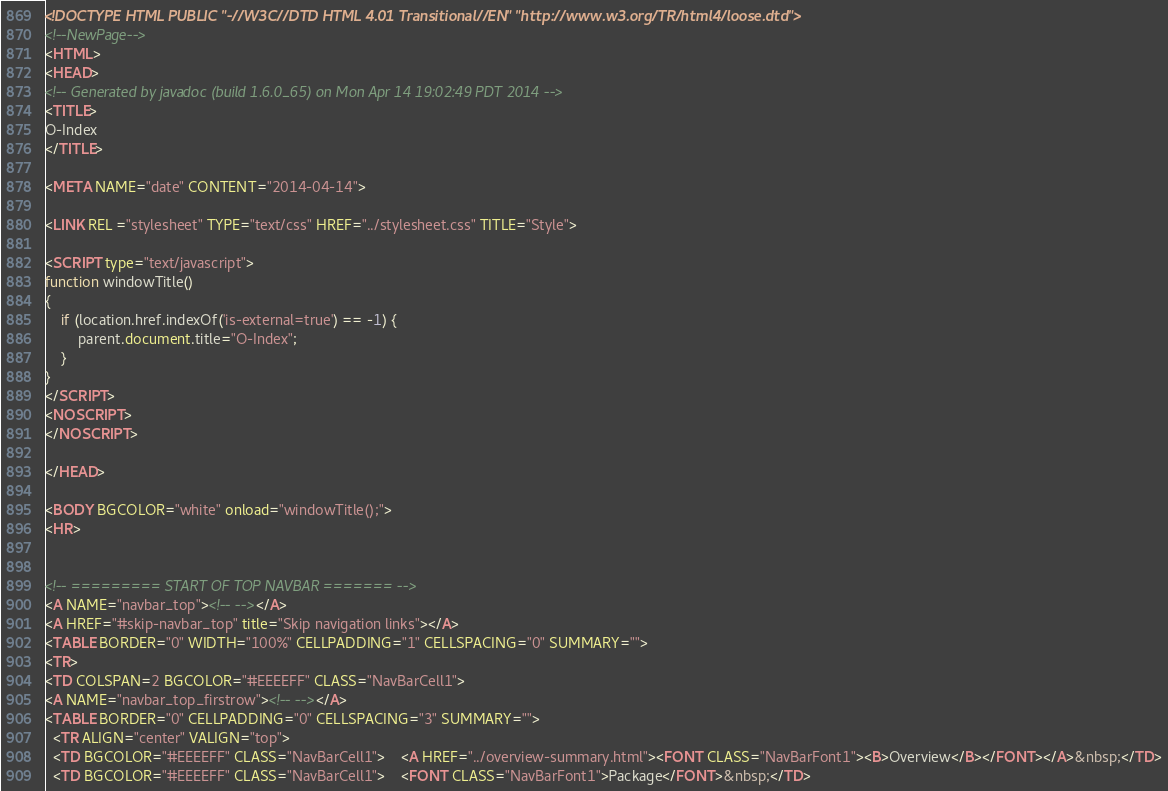<code> <loc_0><loc_0><loc_500><loc_500><_HTML_><!DOCTYPE HTML PUBLIC "-//W3C//DTD HTML 4.01 Transitional//EN" "http://www.w3.org/TR/html4/loose.dtd">
<!--NewPage-->
<HTML>
<HEAD>
<!-- Generated by javadoc (build 1.6.0_65) on Mon Apr 14 19:02:49 PDT 2014 -->
<TITLE>
O-Index
</TITLE>

<META NAME="date" CONTENT="2014-04-14">

<LINK REL ="stylesheet" TYPE="text/css" HREF="../stylesheet.css" TITLE="Style">

<SCRIPT type="text/javascript">
function windowTitle()
{
    if (location.href.indexOf('is-external=true') == -1) {
        parent.document.title="O-Index";
    }
}
</SCRIPT>
<NOSCRIPT>
</NOSCRIPT>

</HEAD>

<BODY BGCOLOR="white" onload="windowTitle();">
<HR>


<!-- ========= START OF TOP NAVBAR ======= -->
<A NAME="navbar_top"><!-- --></A>
<A HREF="#skip-navbar_top" title="Skip navigation links"></A>
<TABLE BORDER="0" WIDTH="100%" CELLPADDING="1" CELLSPACING="0" SUMMARY="">
<TR>
<TD COLSPAN=2 BGCOLOR="#EEEEFF" CLASS="NavBarCell1">
<A NAME="navbar_top_firstrow"><!-- --></A>
<TABLE BORDER="0" CELLPADDING="0" CELLSPACING="3" SUMMARY="">
  <TR ALIGN="center" VALIGN="top">
  <TD BGCOLOR="#EEEEFF" CLASS="NavBarCell1">    <A HREF="../overview-summary.html"><FONT CLASS="NavBarFont1"><B>Overview</B></FONT></A>&nbsp;</TD>
  <TD BGCOLOR="#EEEEFF" CLASS="NavBarCell1">    <FONT CLASS="NavBarFont1">Package</FONT>&nbsp;</TD></code> 